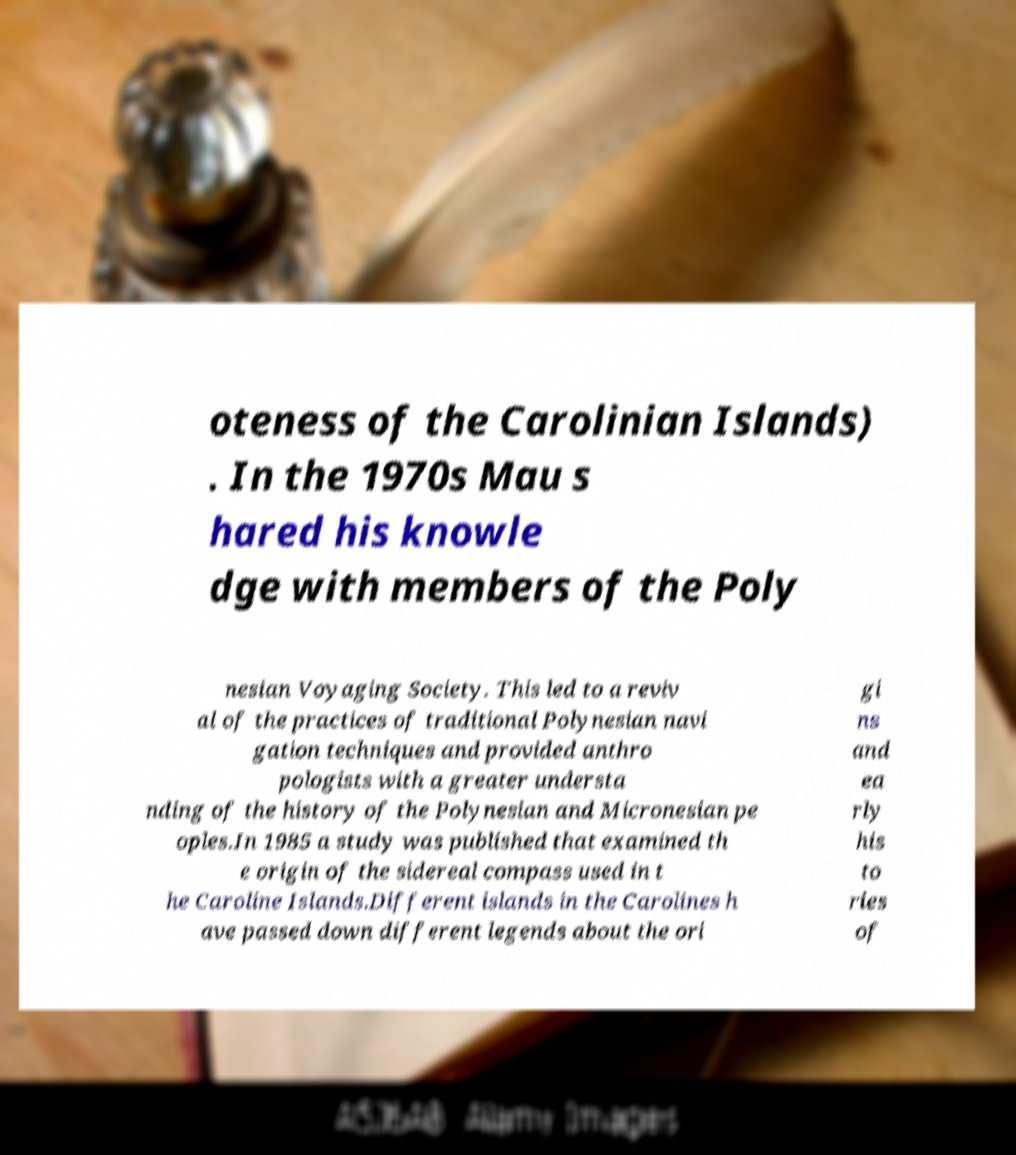Could you assist in decoding the text presented in this image and type it out clearly? oteness of the Carolinian Islands) . In the 1970s Mau s hared his knowle dge with members of the Poly nesian Voyaging Society. This led to a reviv al of the practices of traditional Polynesian navi gation techniques and provided anthro pologists with a greater understa nding of the history of the Polynesian and Micronesian pe oples.In 1985 a study was published that examined th e origin of the sidereal compass used in t he Caroline Islands.Different islands in the Carolines h ave passed down different legends about the ori gi ns and ea rly his to ries of 